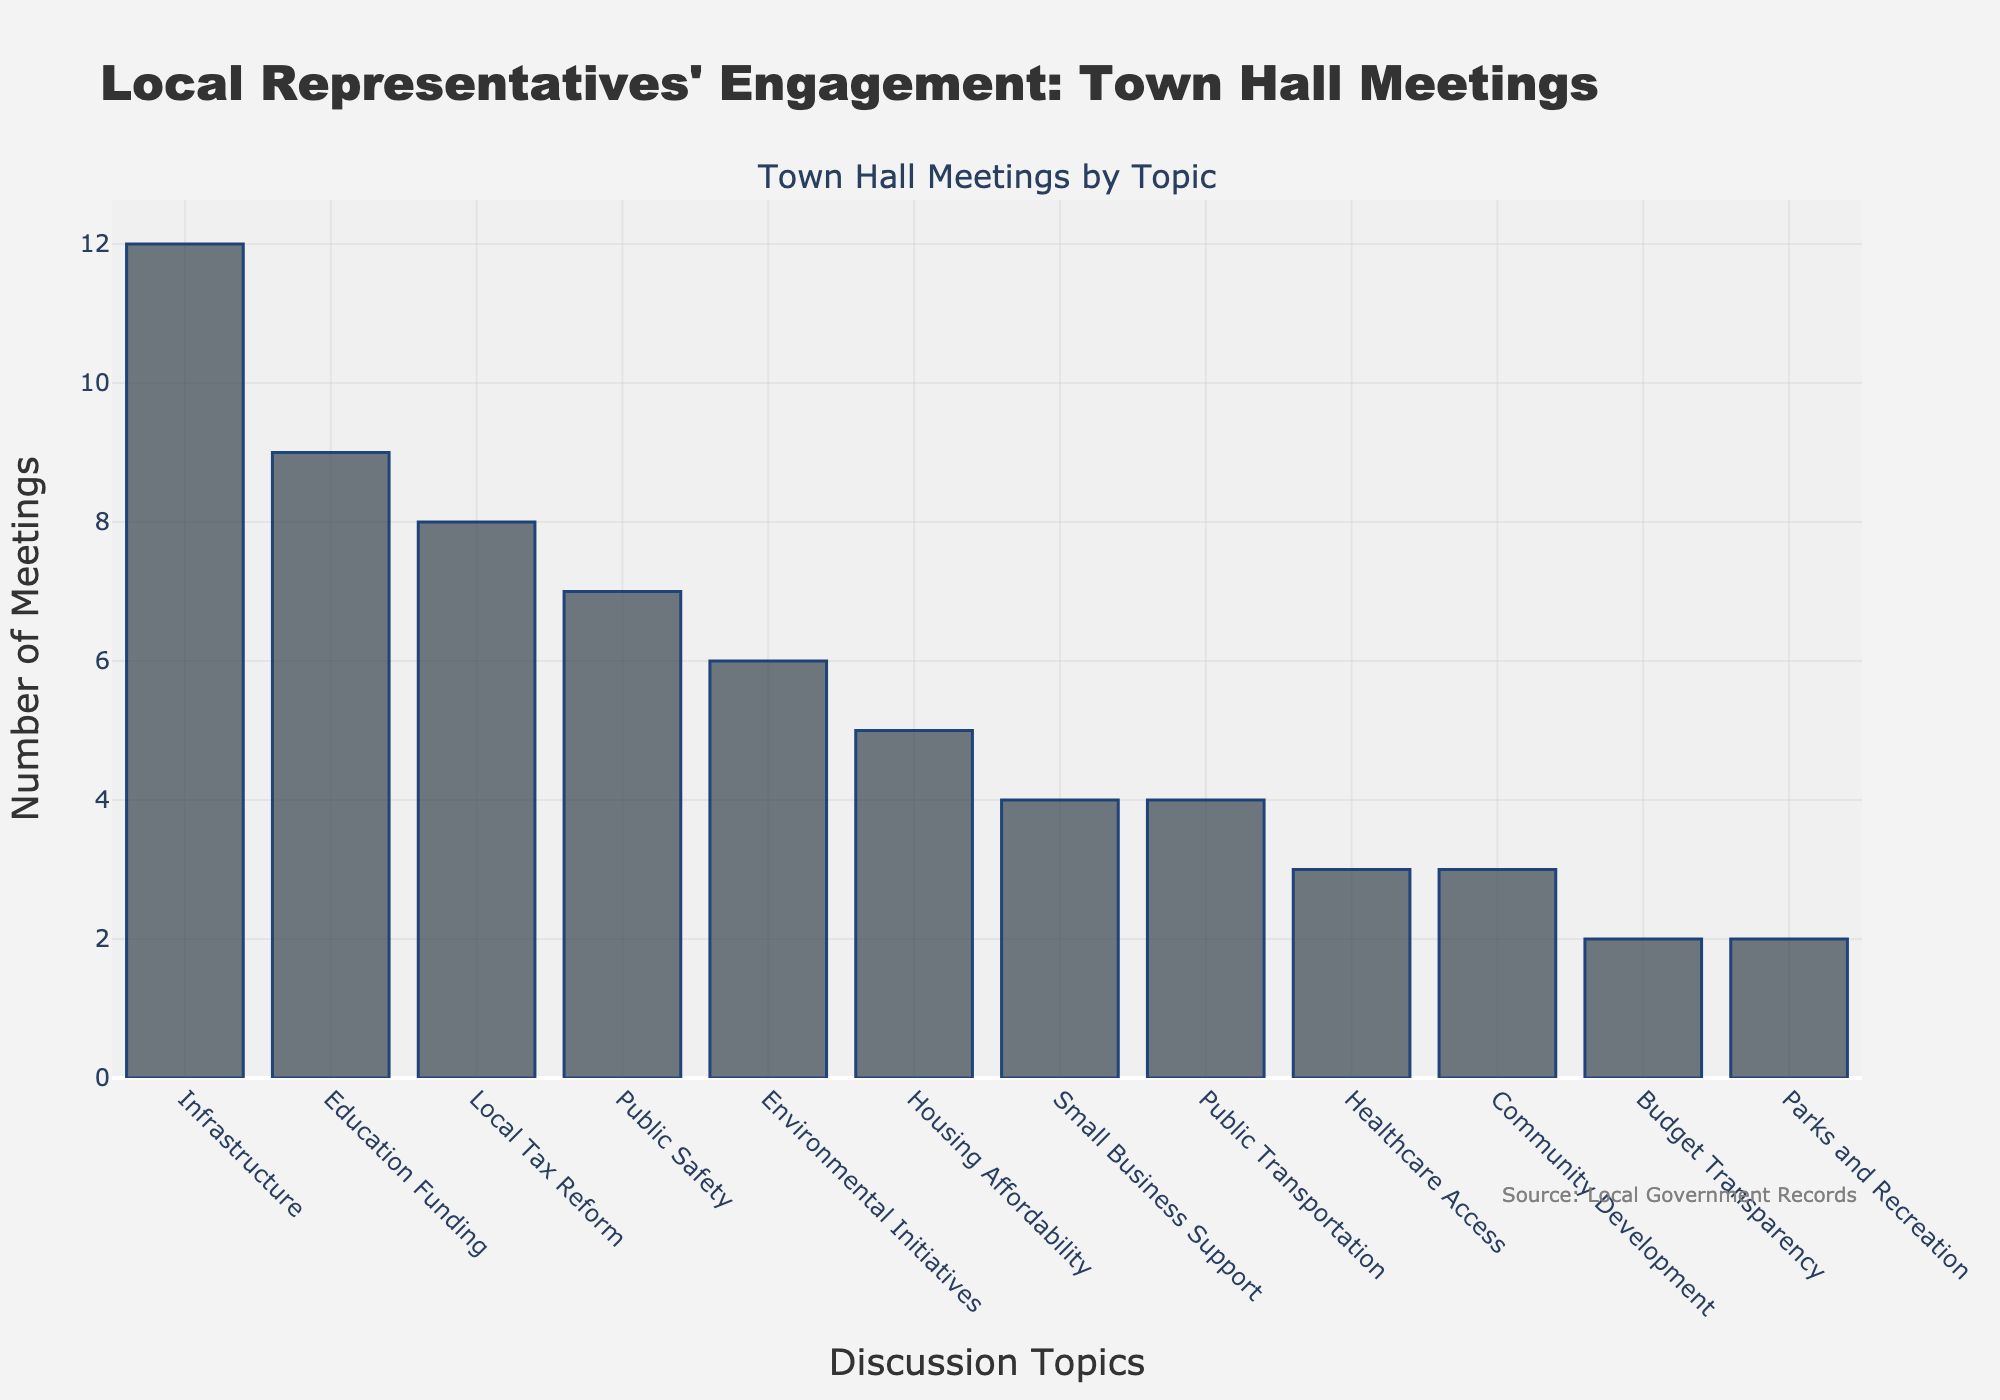How many more town hall meetings were held on Infrastructure compared to Healthcare Access? To find the answer, look at the bars representing Infrastructure and Healthcare Access. Infrastructure has 12 meetings and Healthcare Access has 3 meetings. Subtract the number of meetings for Healthcare Access from Infrastructure: 12 - 3 = 9
Answer: 9 Which topic had the fourth highest number of meetings? Sort the topics by the number of meetings in descending order. The topics with the highest number of meetings are: Infrastructure (12), Education Funding (9), Local Tax Reform (8), and Public Safety (7). The fourth highest is Public Safety with 7 meetings.
Answer: Public Safety What is the total number of town hall meetings held on topics related to public services (Public Safety, Public Transportation)? Identify the relevant topics and sum the number of meetings: Public Safety (7) + Public Transportation (4) = 11
Answer: 11 Which two topics had exactly the same number of town hall meetings? Look for bars of equal height to find topics with the same number of meetings. Both Small Business Support and Public Transportation have 4 meetings each.
Answer: Small Business Support and Public Transportation How many topics had fewer than 5 town hall meetings? Count the number of topics where the bar height indicates fewer than 5 meetings: Housing Affordability (5), Small Business Support (4), Public Transportation (4), Healthcare Access (3), Community Development (3), Budget Transparency (2), and Parks and Recreation (2). Exclude Housing Affordability, as it has exactly 5 meetings. So, there are 6 topics with fewer than 5 meetings.
Answer: 6 By how much does the number of meetings on Environmental Initiatives exceed the combined total for Budget Transparency and Parks and Recreation? Add up the number of meetings for Budget Transparency and Parks and Recreation: 2 + 2 = 4. Then, subtract this total from the number of meetings for Environmental Initiatives: 6 - 4 = 2
Answer: 2 What is the average number of meetings for the topics that had more than 6 meetings? Identify the topics with more than 6 meetings: Infrastructure (12), Education Funding (9), and Local Tax Reform (8). Sum the numbers and divide by the count of topics: (12 + 9 + 8) / 3 = 29 / 3 = 9.67 (approximately)
Answer: 9.67 How many topics had more meetings than Housing Affordability? Housing Affordability has 5 meetings. Count the topics with a higher number: Infrastructure (12), Education Funding (9), Local Tax Reform (8), Public Safety (7), Environmental Initiatives (6). Thus, there are 5 topics with more meetings.
Answer: 5 Which discussion topics had their bars colored most distinctively compared to others? This is a visual difference question. Notice the bars' visual distinctiveness, especially those with more evident color or length, implying higher values. Infrastructure, Education Funding, and Local Tax Reform stand out due to their noticeably taller bars.
Answer: Infrastructure, Education Funding, Local Tax Reform 